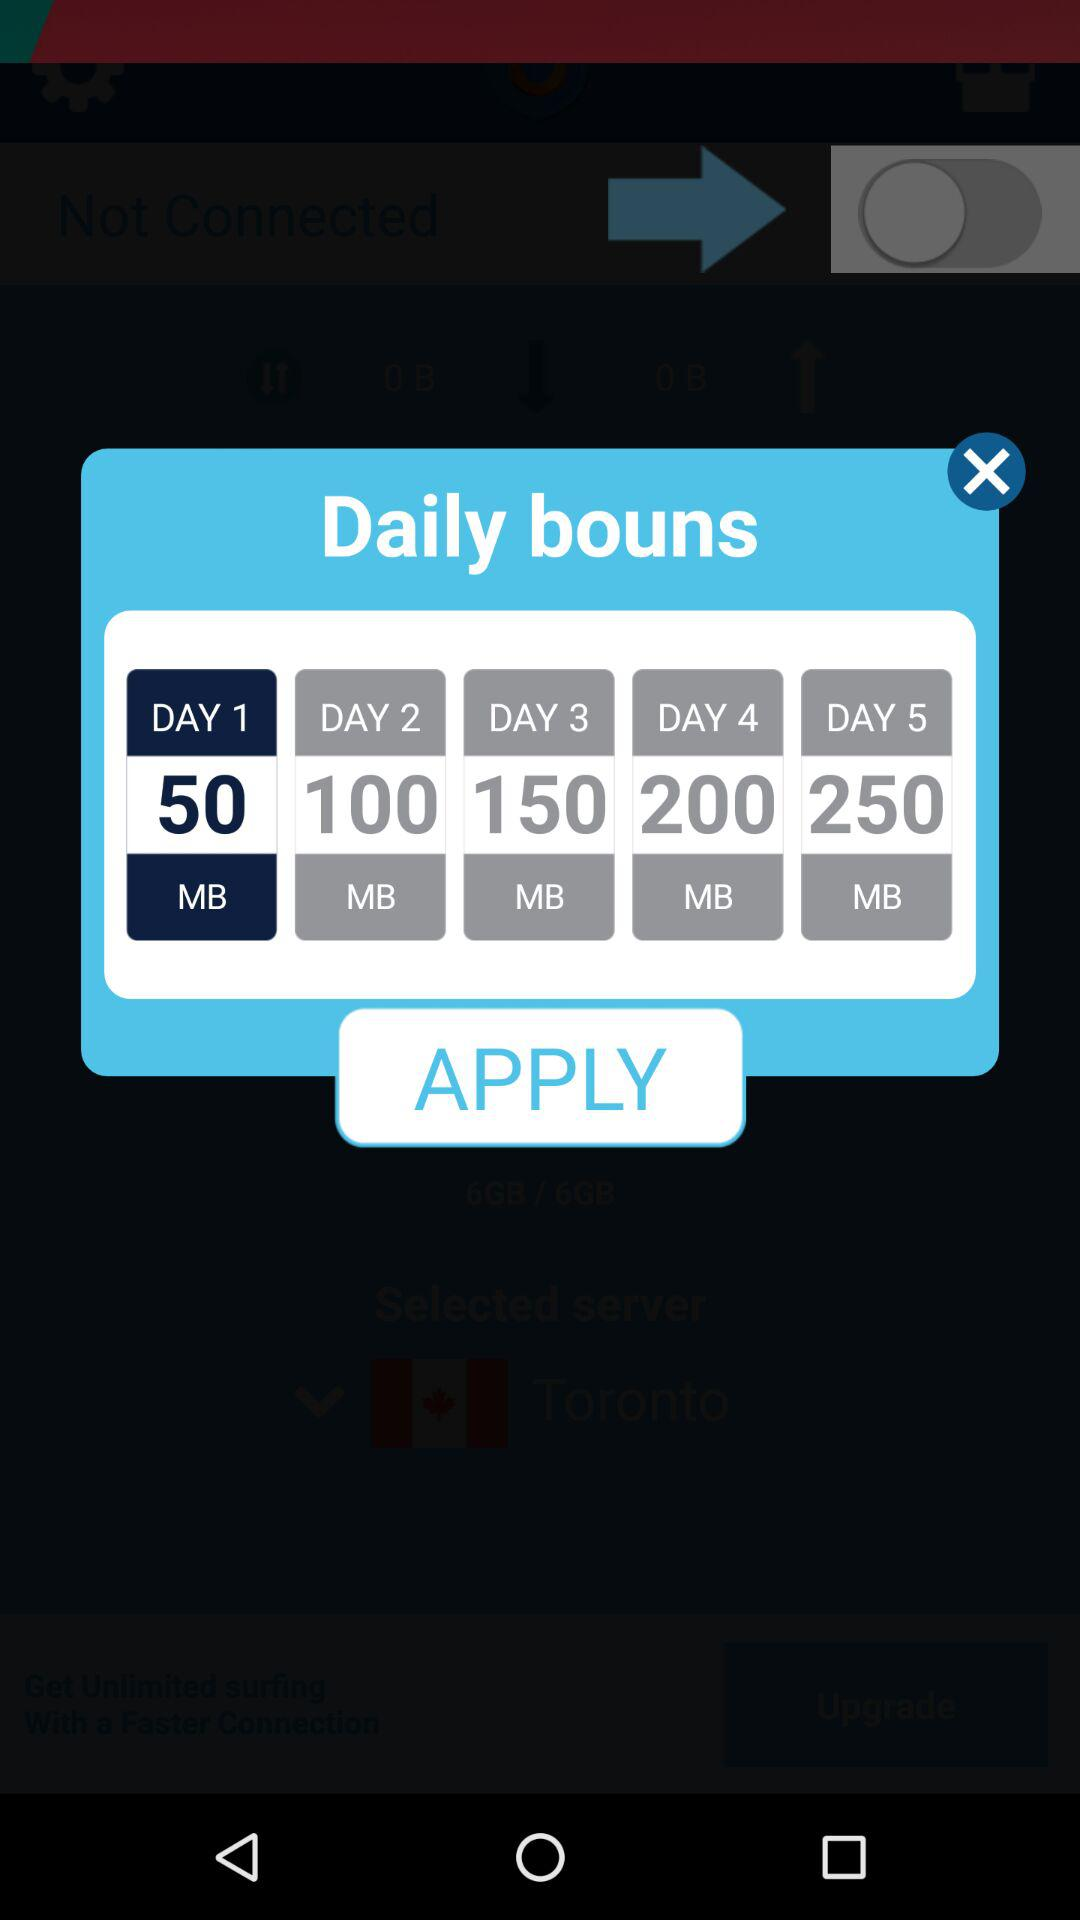What is the selected day? The selected day is 1. 